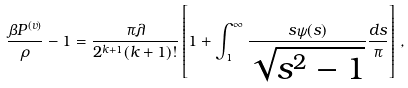Convert formula to latex. <formula><loc_0><loc_0><loc_500><loc_500>\frac { \beta P ^ { ( v ) } } { \rho } - 1 = \frac { \pi \lambda } { 2 ^ { k + 1 } ( k + 1 ) ! } \left [ 1 + \int _ { 1 } ^ { \infty } \frac { s \psi ( s ) } { \sqrt { s ^ { 2 } - 1 } } \frac { d s } { \pi } \right ] \, ,</formula> 